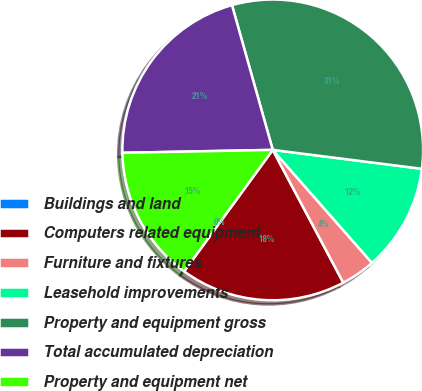Convert chart to OTSL. <chart><loc_0><loc_0><loc_500><loc_500><pie_chart><fcel>Buildings and land<fcel>Computers related equipment<fcel>Furniture and fixtures<fcel>Leasehold improvements<fcel>Property and equipment gross<fcel>Total accumulated depreciation<fcel>Property and equipment net<nl><fcel>0.0%<fcel>17.8%<fcel>3.7%<fcel>11.52%<fcel>31.38%<fcel>20.94%<fcel>14.66%<nl></chart> 